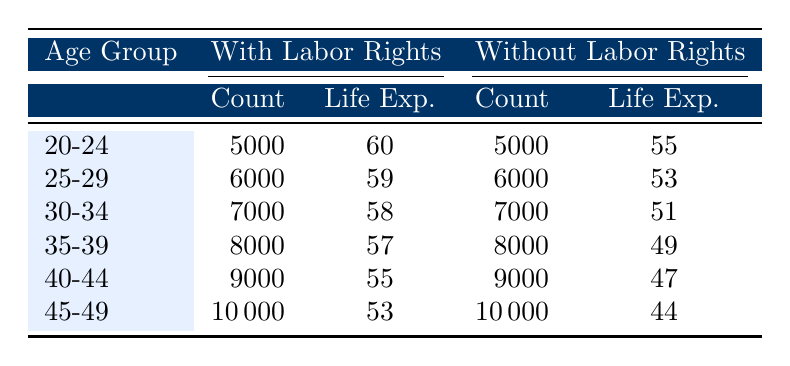What is the expected life years for employees with labor rights in the age group 30-34? The table shows that for the age group 30-34, employees with labor rights have an expected life span of 58 years.
Answer: 58 How many employees without labor rights are in the age group 40-44? According to the table, there are 9000 employees without labor rights in the age group 40-44.
Answer: 9000 What is the difference in life expectancy between employees with and without labor rights in the age group 45-49? For employees in the age group 45-49, the life expectancy is 53 years for those with labor rights and 44 years for those without. The difference is 53 - 44 = 9 years.
Answer: 9 Is the life expectancy for employees without labor rights consistently lower across all age groups? Yes, by examining the table, it is evident that the life expectancy for employees without labor rights is lower in every listed age group compared to those with labor rights.
Answer: Yes What is the average expected life years for employees with labor rights across all age groups? The expected life years for employees with labor rights are 60, 59, 58, 57, 55, and 53. Adding these (60 + 59 + 58 + 57 + 55 + 53 = 342) gives a total of 342 years. There are 6 age groups, so the average is 342 / 6 = 57.
Answer: 57 What is the total number of employees with labor rights across all age groups? The total count of employees with labor rights is the sum of all the counts for each age group: 5000 + 6000 + 7000 + 8000 + 9000 + 10000 = 45000.
Answer: 45000 Which age group has the highest life expectancy for employees without labor rights? By checking the life expectancy values for employees without labor rights, the age group 20-24 has the highest life expectancy at 55 years.
Answer: 20-24 What is the median expected life years for employees with labor rights from all age groups? Sorting the expected life years for employees with labor rights gives us a sequence of 60, 59, 58, 57, 55, 53. The median is the average of the 3rd and 4th values (58 and 57); thus, (58 + 57) / 2 = 57.5.
Answer: 57.5 